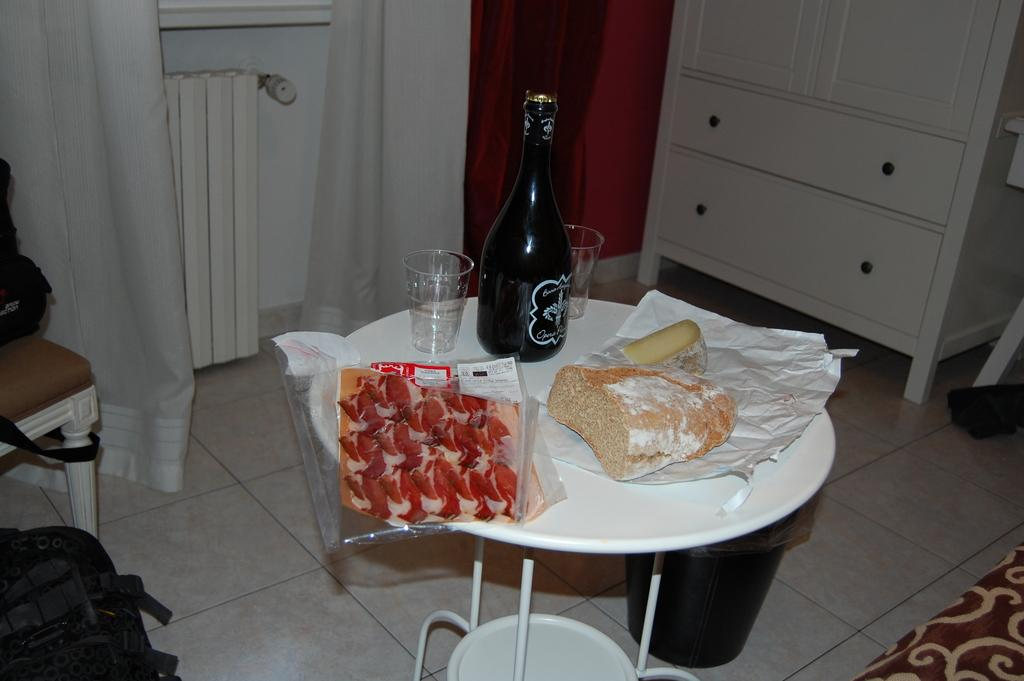What object is present on the floor in the image? There is a stool in the image. What is placed on the stool? There is a bottle and glasses on the stool. Are there any additional features on the stool? Yes, there are covers on the stool. What color are the curtains in the image? The curtains are white and red in color. What is the color of the floor in the image? The floor is white in color. How many toes can be seen on the person standing next to the stool in the image? There is no person standing next to the stool in the image, so no toes can be seen. What type of territory is depicted in the image? The image does not depict any territory; it shows a stool, a bottle, glasses, covers, curtains, and a floor. 